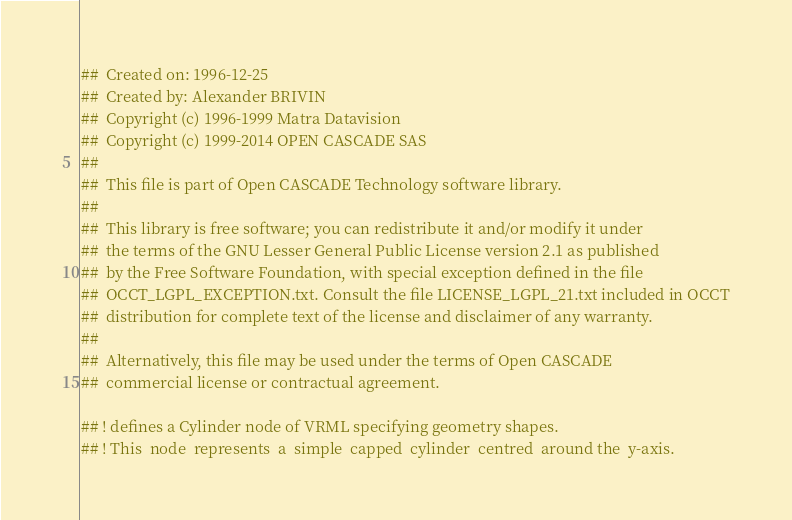<code> <loc_0><loc_0><loc_500><loc_500><_Nim_>##  Created on: 1996-12-25
##  Created by: Alexander BRIVIN
##  Copyright (c) 1996-1999 Matra Datavision
##  Copyright (c) 1999-2014 OPEN CASCADE SAS
##
##  This file is part of Open CASCADE Technology software library.
##
##  This library is free software; you can redistribute it and/or modify it under
##  the terms of the GNU Lesser General Public License version 2.1 as published
##  by the Free Software Foundation, with special exception defined in the file
##  OCCT_LGPL_EXCEPTION.txt. Consult the file LICENSE_LGPL_21.txt included in OCCT
##  distribution for complete text of the license and disclaimer of any warranty.
##
##  Alternatively, this file may be used under the terms of Open CASCADE
##  commercial license or contractual agreement.

## ! defines a Cylinder node of VRML specifying geometry shapes.
## ! This  node  represents  a  simple  capped  cylinder  centred  around the  y-axis.</code> 